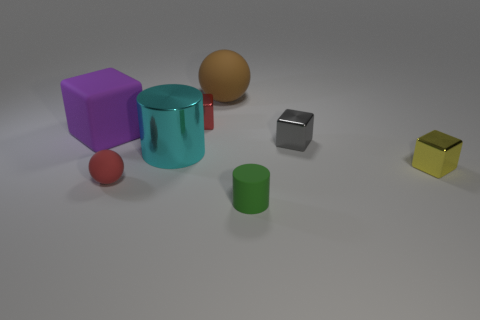Is there anything else that has the same shape as the big cyan metallic object? The big cyan metallic object appears to be a cylinder, and there is another smaller green cylinder that shares its shape. 